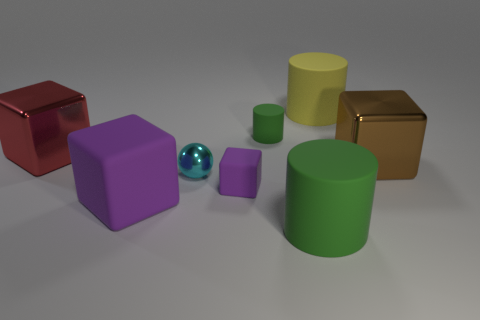Subtract 1 cubes. How many cubes are left? 3 Add 1 red shiny things. How many objects exist? 9 Subtract all cylinders. How many objects are left? 5 Add 4 big rubber objects. How many big rubber objects exist? 7 Subtract 0 cyan cylinders. How many objects are left? 8 Subtract all large blue cubes. Subtract all tiny cyan metal spheres. How many objects are left? 7 Add 6 brown shiny things. How many brown shiny things are left? 7 